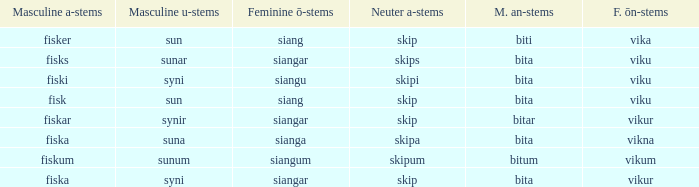What is the an-stem for the word which has an ö-stems of siangar and an u-stem ending of syni? Bita. 